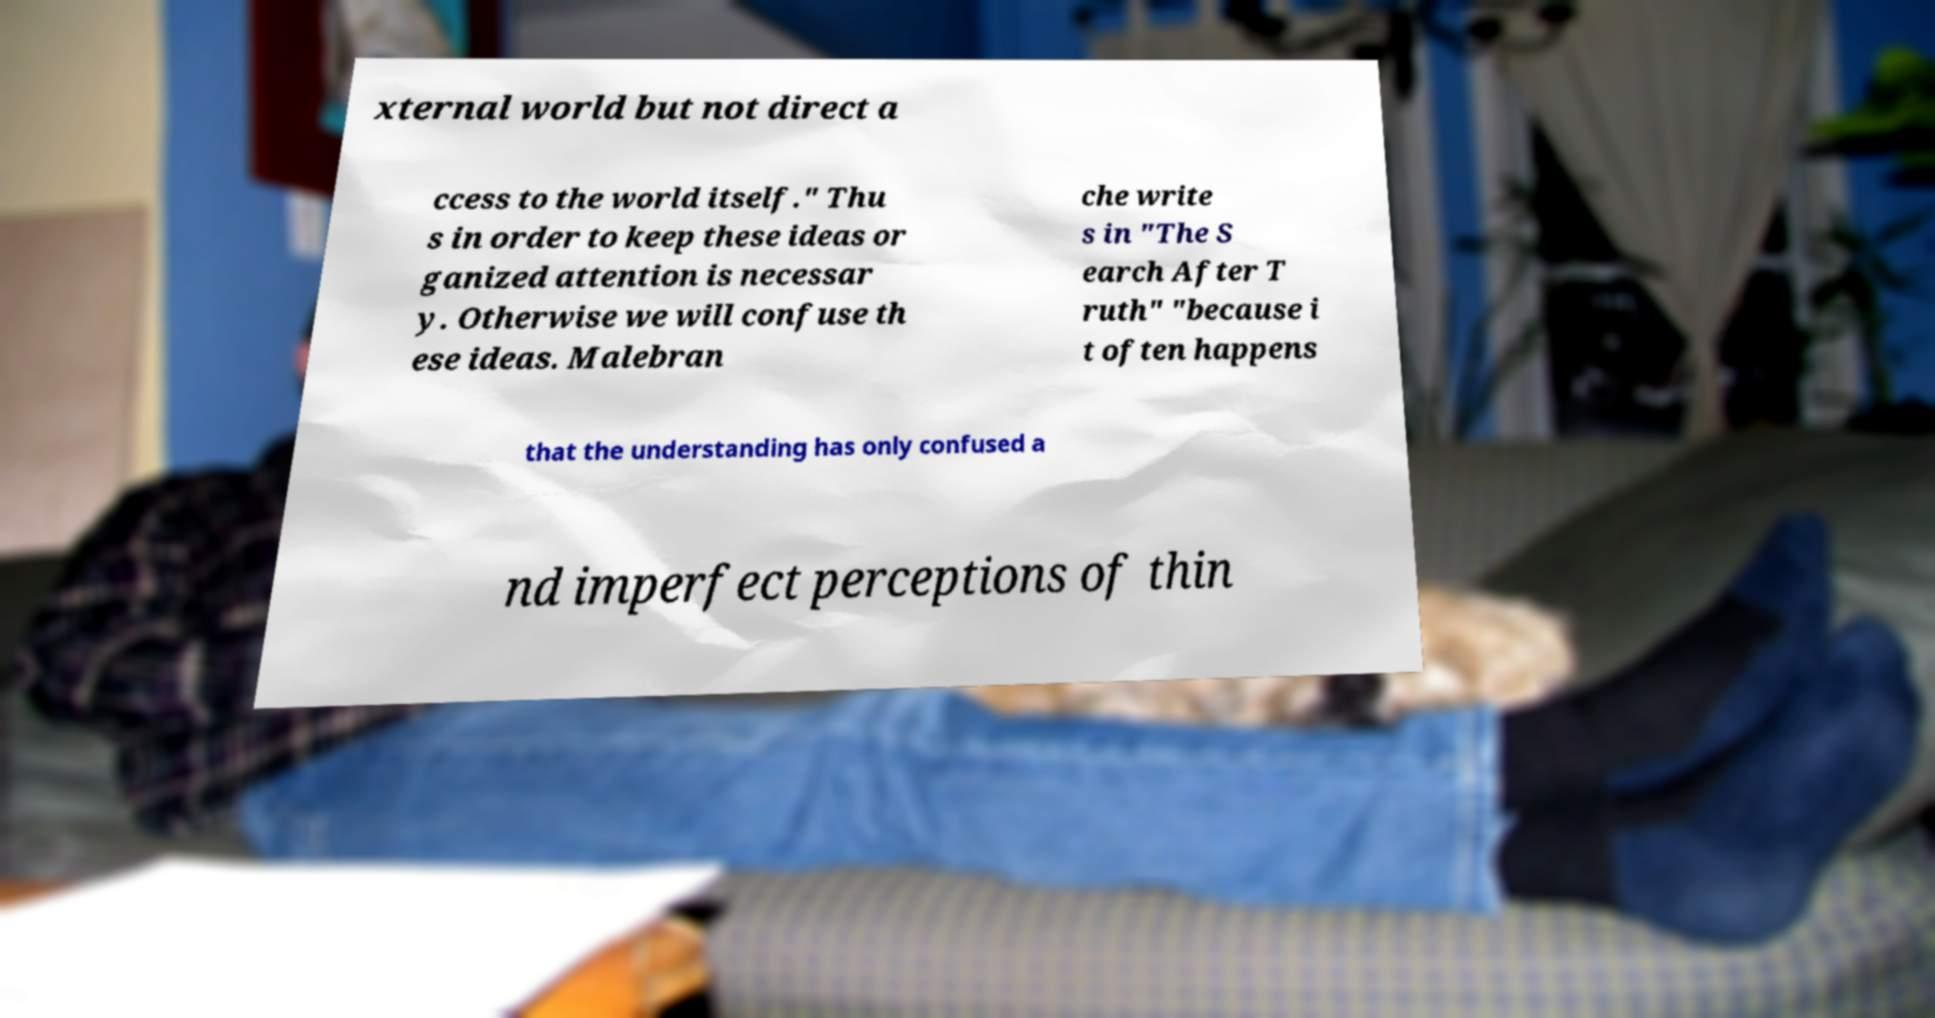Can you read and provide the text displayed in the image?This photo seems to have some interesting text. Can you extract and type it out for me? xternal world but not direct a ccess to the world itself." Thu s in order to keep these ideas or ganized attention is necessar y. Otherwise we will confuse th ese ideas. Malebran che write s in "The S earch After T ruth" "because i t often happens that the understanding has only confused a nd imperfect perceptions of thin 